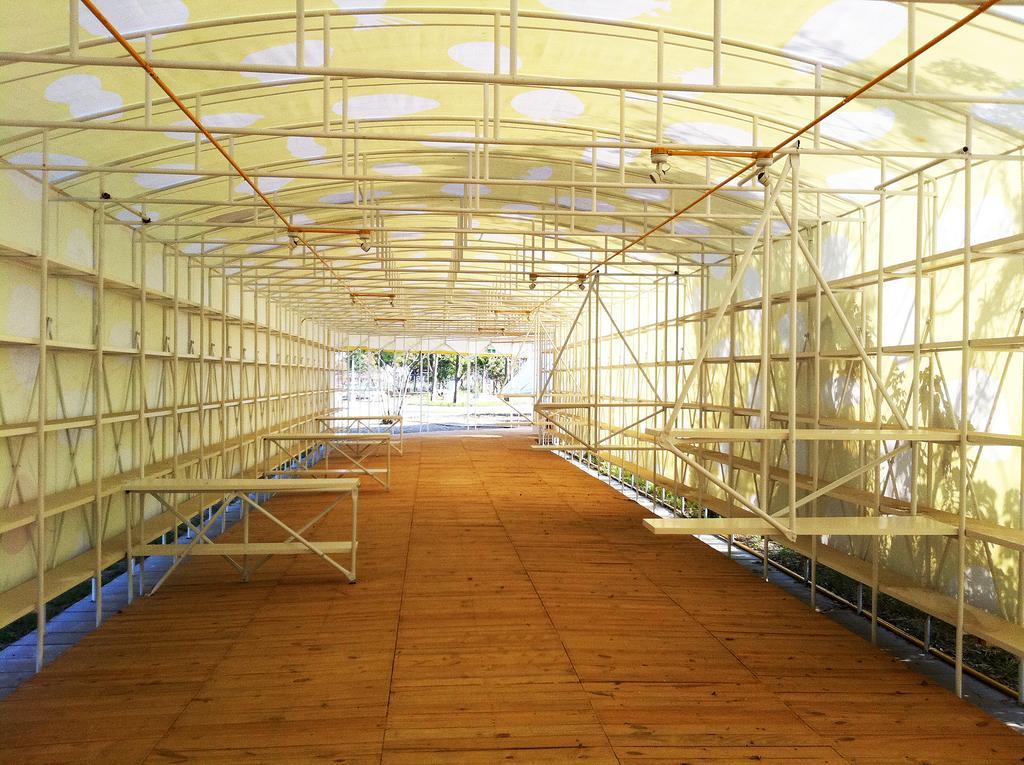Can you describe this image briefly? In this image I can see benches, metal rods, shed, trees and poles. This image is taken may be during a day. 